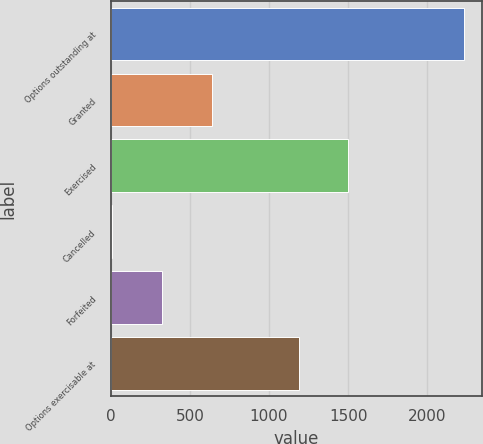<chart> <loc_0><loc_0><loc_500><loc_500><bar_chart><fcel>Options outstanding at<fcel>Granted<fcel>Exercised<fcel>Cancelled<fcel>Forfeited<fcel>Options exercisable at<nl><fcel>2233<fcel>636<fcel>1502.5<fcel>9<fcel>322.5<fcel>1189<nl></chart> 